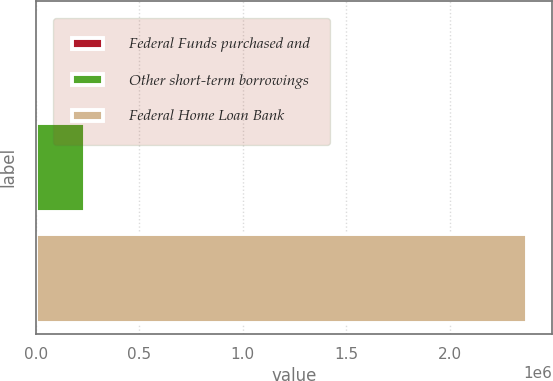<chart> <loc_0><loc_0><loc_500><loc_500><bar_chart><fcel>Federal Funds purchased and<fcel>Other short-term borrowings<fcel>Federal Home Loan Bank<nl><fcel>0.08<fcel>237500<fcel>2.375e+06<nl></chart> 